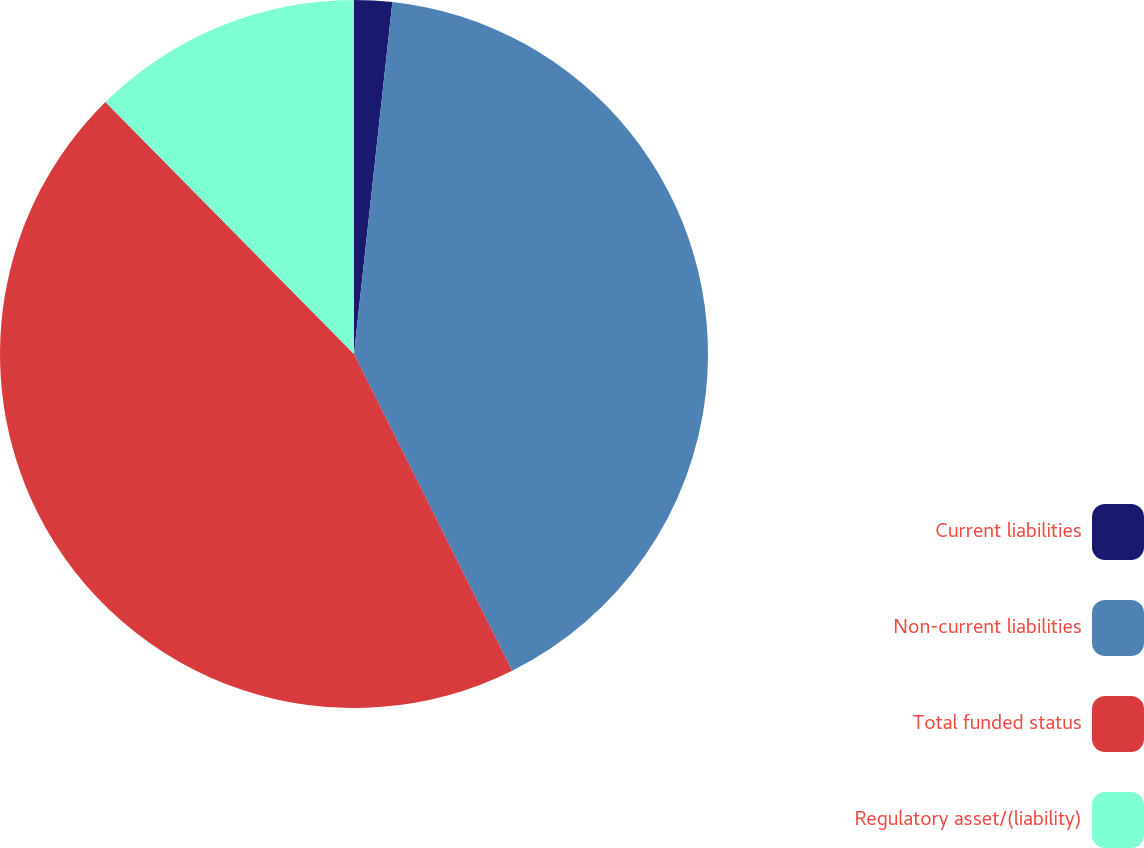<chart> <loc_0><loc_0><loc_500><loc_500><pie_chart><fcel>Current liabilities<fcel>Non-current liabilities<fcel>Total funded status<fcel>Regulatory asset/(liability)<nl><fcel>1.73%<fcel>40.9%<fcel>44.99%<fcel>12.39%<nl></chart> 